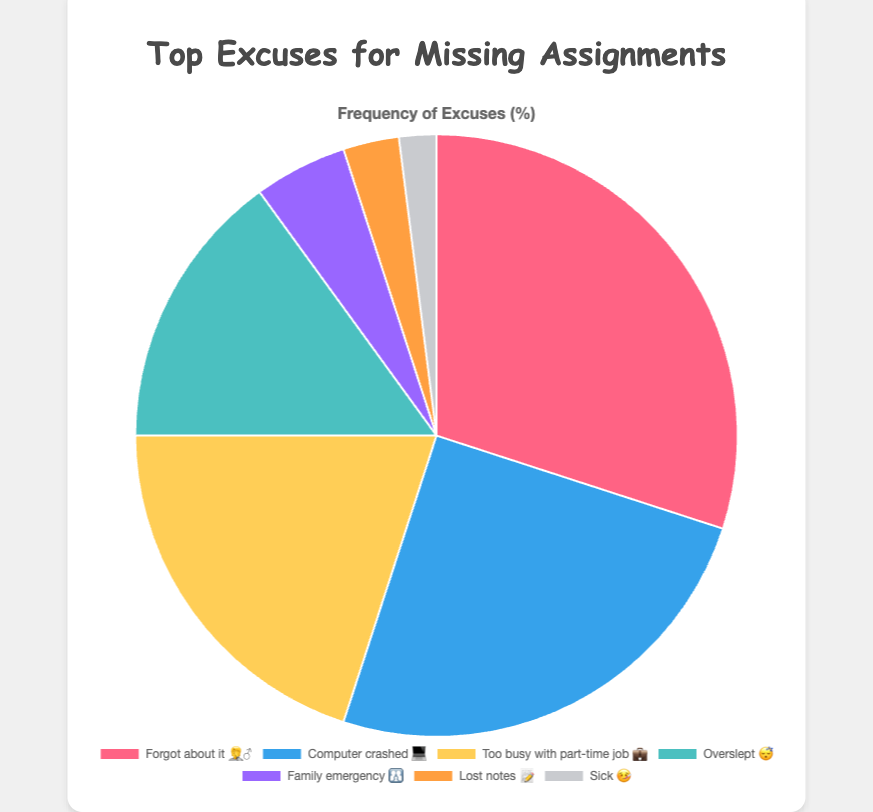What's the most common excuse used for missing assignments? The slice with the highest percentage in the pie chart corresponds to "Forgot about it" with 🤦‍♂️ emoji, indicating 30%.
Answer: "Forgot about it" 🤦‍♂️ How many excuses are listed in the chart? Count the number of labels or slices in the pie chart. There are 7 excuses: "Forgot about it," "Computer crashed," "Too busy with part-time job," "Overslept," "Family emergency," "Lost notes," and "Sick."
Answer: 7 Which excuse has the least frequency? The smallest slice in the pie chart corresponds to "Sick" with 🤒 emoji, indicating 2%.
Answer: "Sick" 🤒 What's the total percentage of the two least frequent excuses? Add the frequencies of the "Lost notes" (3%) and "Sick" (2%) excuses.
Answer: 5% Which excuse is more frequent: "Too busy with part-time job" or "Overslept"? Compare the slices for "Too busy with part-time job" 💼 (20%) and "Overslept" 😴 (15%).
Answer: "Too busy with part-time job" 💼 If you combine the top three excuses, what percentage of excuses do they account for? Add the frequencies of the top three excuses: 30% ("Forgot about it" 🤦‍♂️), 25% ("Computer crashed" 💻), and 20% ("Too busy with part-time job" 💼), summing to 75%.
Answer: 75% Which emoji is used for the excuse with a frequency of 25%? Identify the slice labeled "Computer crashed" and note its emoji 💻.
Answer: 💻 Is the "Family emergency" excuse used more or less frequently than "Overslept"? Compare their frequencies: "Family emergency" 👪 (5%) vs. "Overslept" 😴 (15%).
Answer: Less What's the difference in frequency between "Forgot about it" and "Computer crashed"? Subtract the frequency of "Computer crashed" (25%) from "Forgot about it" (30%).
Answer: 5% Are there more excuses related to technical issues or personal reasons? Group the excuses into "technical issues" (e.g., "Computer crashed" 💻) and "personal reasons" (e.g., "Too busy with part-time job" 💼, "Family emergency" 👪, "Overslept" 😴, "Forgot about it" 🤦‍♂️, "Lost notes" 📝, "Sick" 🤒), then compare their total frequencies. Personal reasons are more frequent (75% + 15% + 5% + 3% + 2% = 95%) than technical issues (25%).
Answer: Personal reasons 